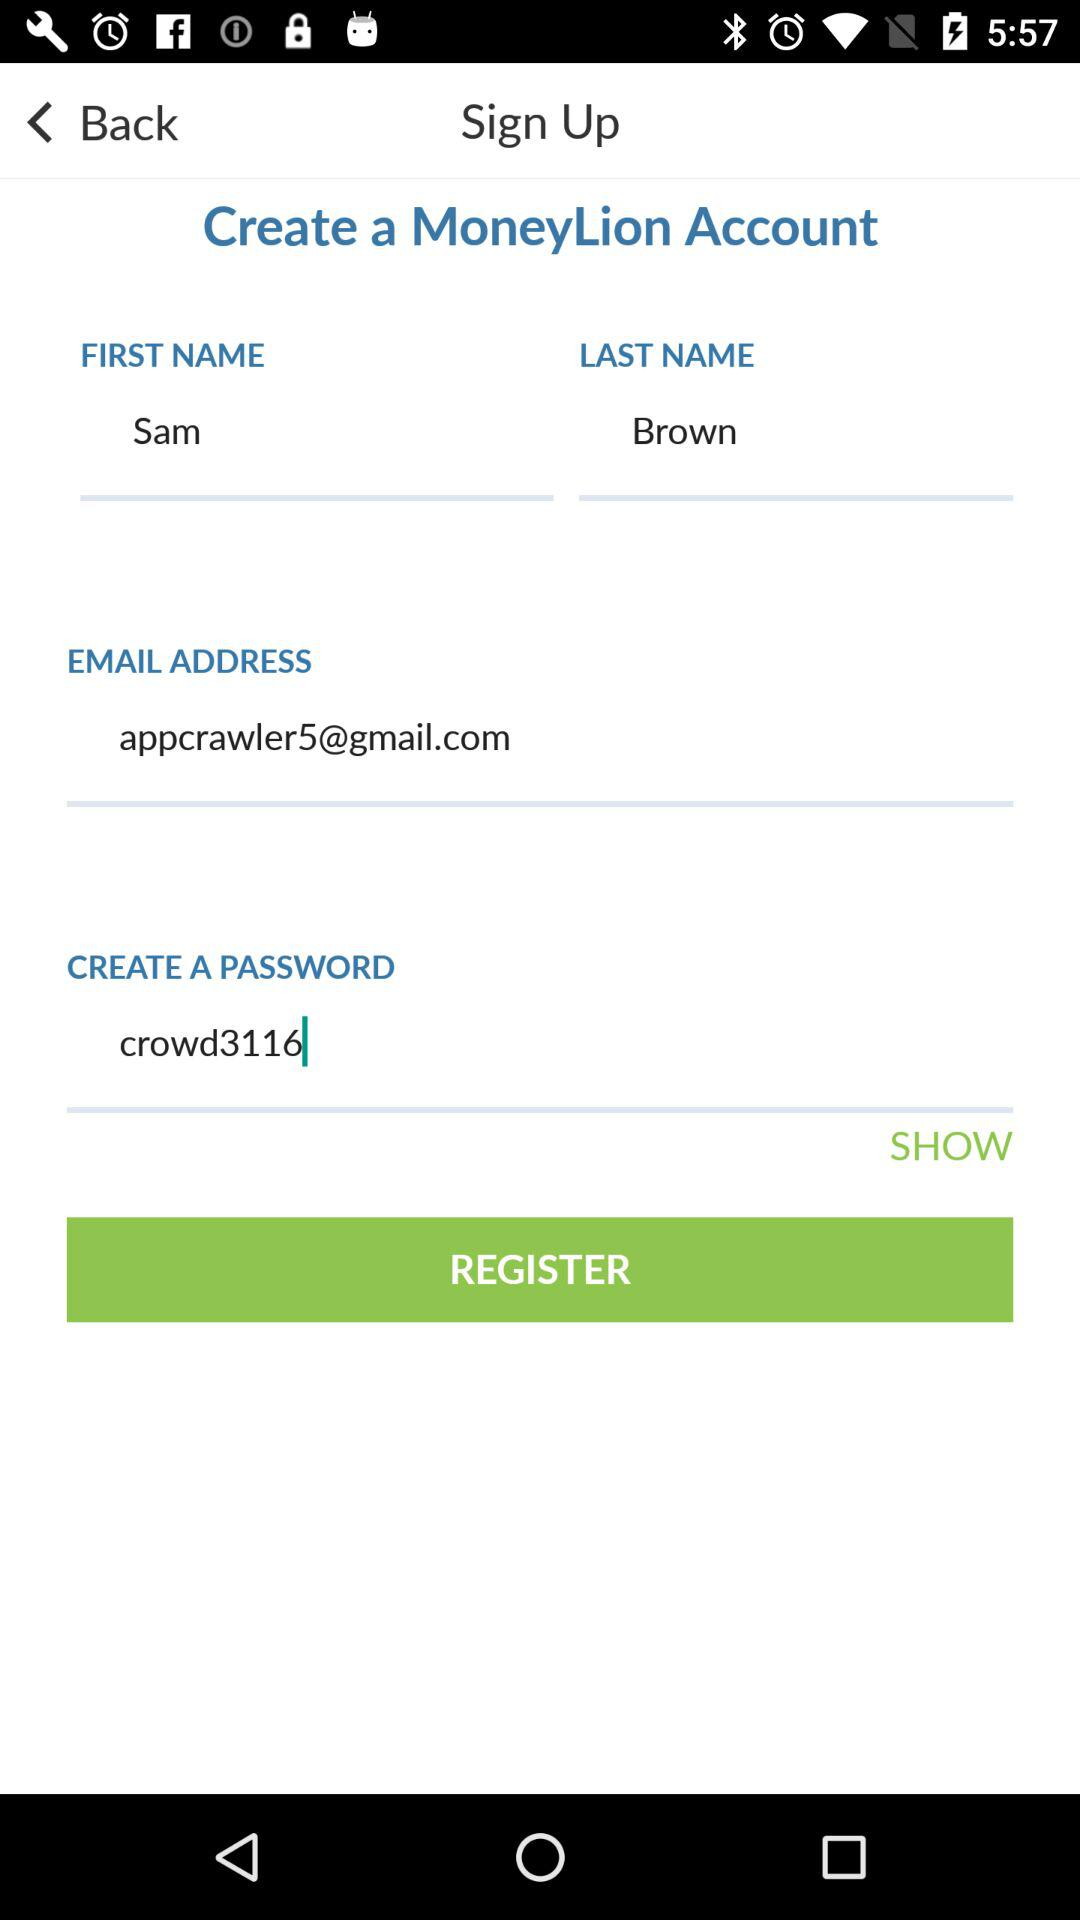What is the first name of the user? The first name of the user is Sam. 